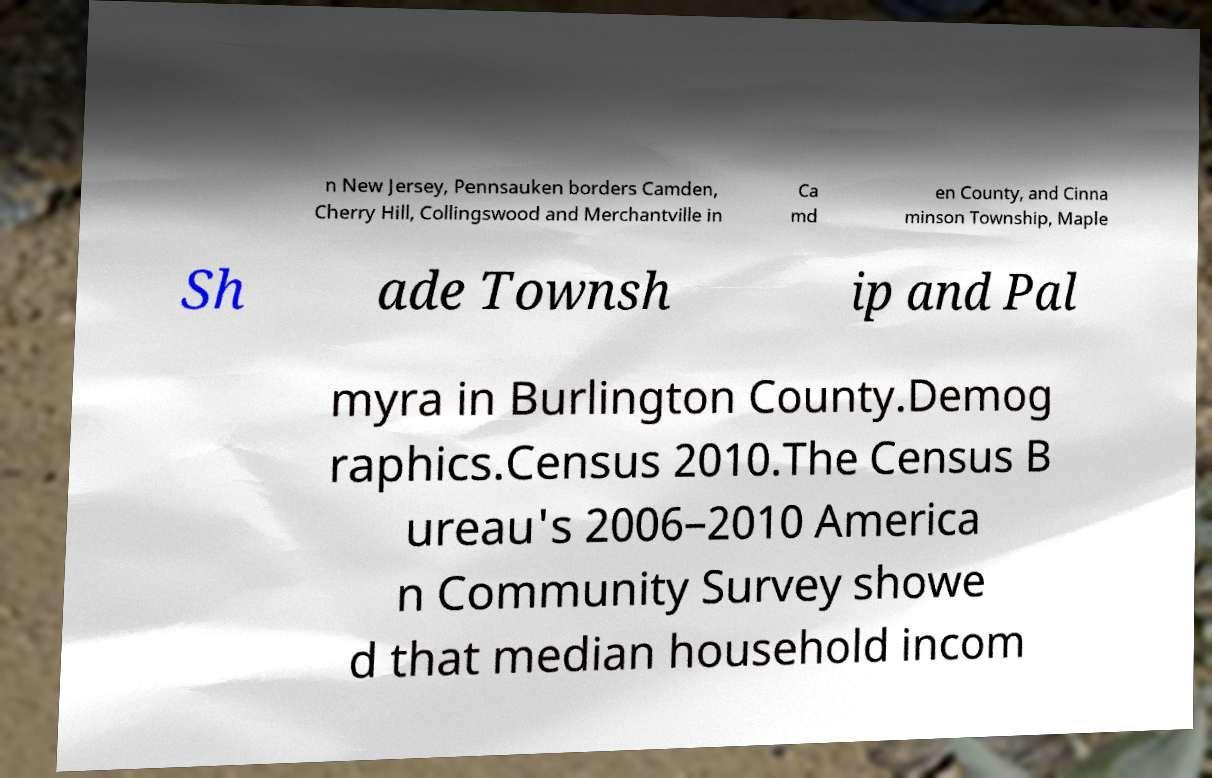Can you accurately transcribe the text from the provided image for me? n New Jersey, Pennsauken borders Camden, Cherry Hill, Collingswood and Merchantville in Ca md en County, and Cinna minson Township, Maple Sh ade Townsh ip and Pal myra in Burlington County.Demog raphics.Census 2010.The Census B ureau's 2006–2010 America n Community Survey showe d that median household incom 